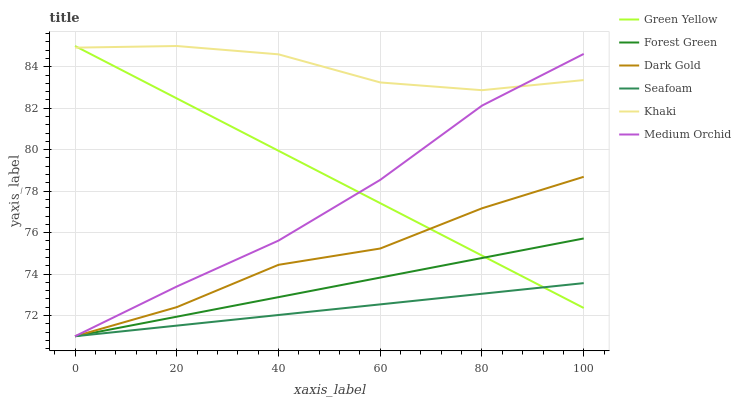Does Seafoam have the minimum area under the curve?
Answer yes or no. Yes. Does Khaki have the maximum area under the curve?
Answer yes or no. Yes. Does Dark Gold have the minimum area under the curve?
Answer yes or no. No. Does Dark Gold have the maximum area under the curve?
Answer yes or no. No. Is Forest Green the smoothest?
Answer yes or no. Yes. Is Dark Gold the roughest?
Answer yes or no. Yes. Is Medium Orchid the smoothest?
Answer yes or no. No. Is Medium Orchid the roughest?
Answer yes or no. No. Does Dark Gold have the lowest value?
Answer yes or no. Yes. Does Green Yellow have the lowest value?
Answer yes or no. No. Does Green Yellow have the highest value?
Answer yes or no. Yes. Does Dark Gold have the highest value?
Answer yes or no. No. Is Dark Gold less than Khaki?
Answer yes or no. Yes. Is Khaki greater than Dark Gold?
Answer yes or no. Yes. Does Seafoam intersect Green Yellow?
Answer yes or no. Yes. Is Seafoam less than Green Yellow?
Answer yes or no. No. Is Seafoam greater than Green Yellow?
Answer yes or no. No. Does Dark Gold intersect Khaki?
Answer yes or no. No. 